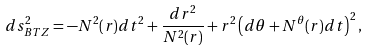<formula> <loc_0><loc_0><loc_500><loc_500>d s ^ { 2 } _ { B T Z } = - N ^ { 2 } ( r ) d t ^ { 2 } + \frac { d r ^ { 2 } } { N ^ { 2 } ( r ) } + r ^ { 2 } \left ( d \theta + N ^ { \theta } ( r ) d t \right ) ^ { 2 } ,</formula> 